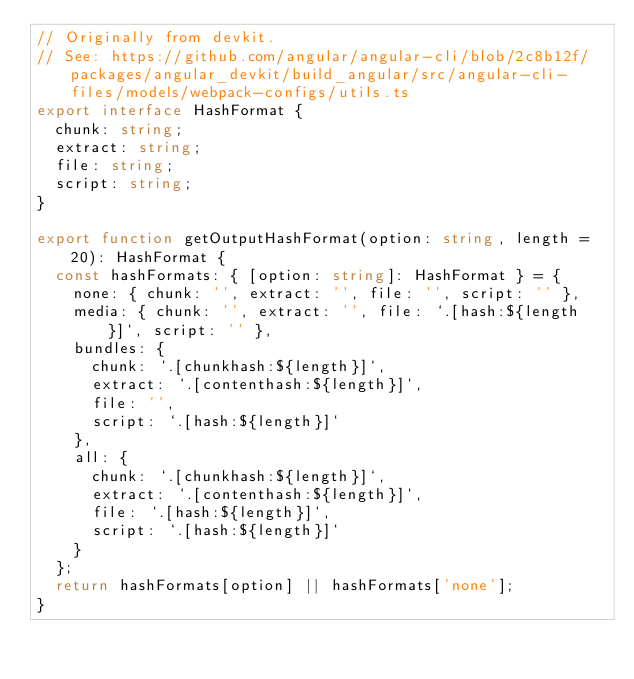Convert code to text. <code><loc_0><loc_0><loc_500><loc_500><_TypeScript_>// Originally from devkit.
// See: https://github.com/angular/angular-cli/blob/2c8b12f/packages/angular_devkit/build_angular/src/angular-cli-files/models/webpack-configs/utils.ts
export interface HashFormat {
  chunk: string;
  extract: string;
  file: string;
  script: string;
}

export function getOutputHashFormat(option: string, length = 20): HashFormat {
  const hashFormats: { [option: string]: HashFormat } = {
    none: { chunk: '', extract: '', file: '', script: '' },
    media: { chunk: '', extract: '', file: `.[hash:${length}]`, script: '' },
    bundles: {
      chunk: `.[chunkhash:${length}]`,
      extract: `.[contenthash:${length}]`,
      file: '',
      script: `.[hash:${length}]`
    },
    all: {
      chunk: `.[chunkhash:${length}]`,
      extract: `.[contenthash:${length}]`,
      file: `.[hash:${length}]`,
      script: `.[hash:${length}]`
    }
  };
  return hashFormats[option] || hashFormats['none'];
}
</code> 